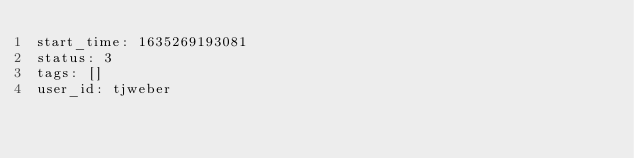<code> <loc_0><loc_0><loc_500><loc_500><_YAML_>start_time: 1635269193081
status: 3
tags: []
user_id: tjweber
</code> 